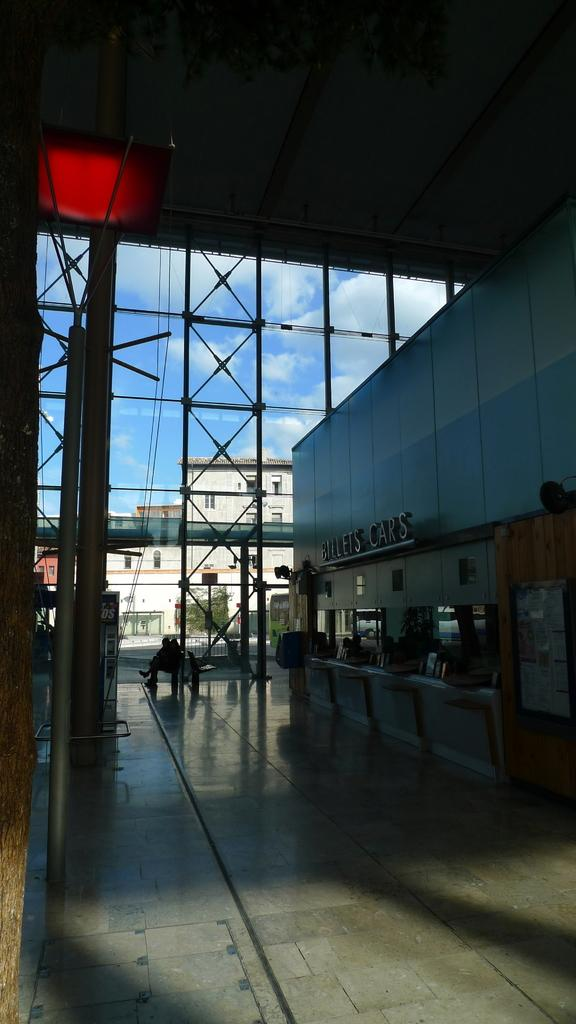What type of location is depicted in the image? The image shows an inside view of a building. What can be seen in the background of the image? There are buildings and the sky visible in the background of the image. Where is the scarecrow located in the image? There is no scarecrow present in the image. What type of drink is being served in the image? There is no drink present in the image. 